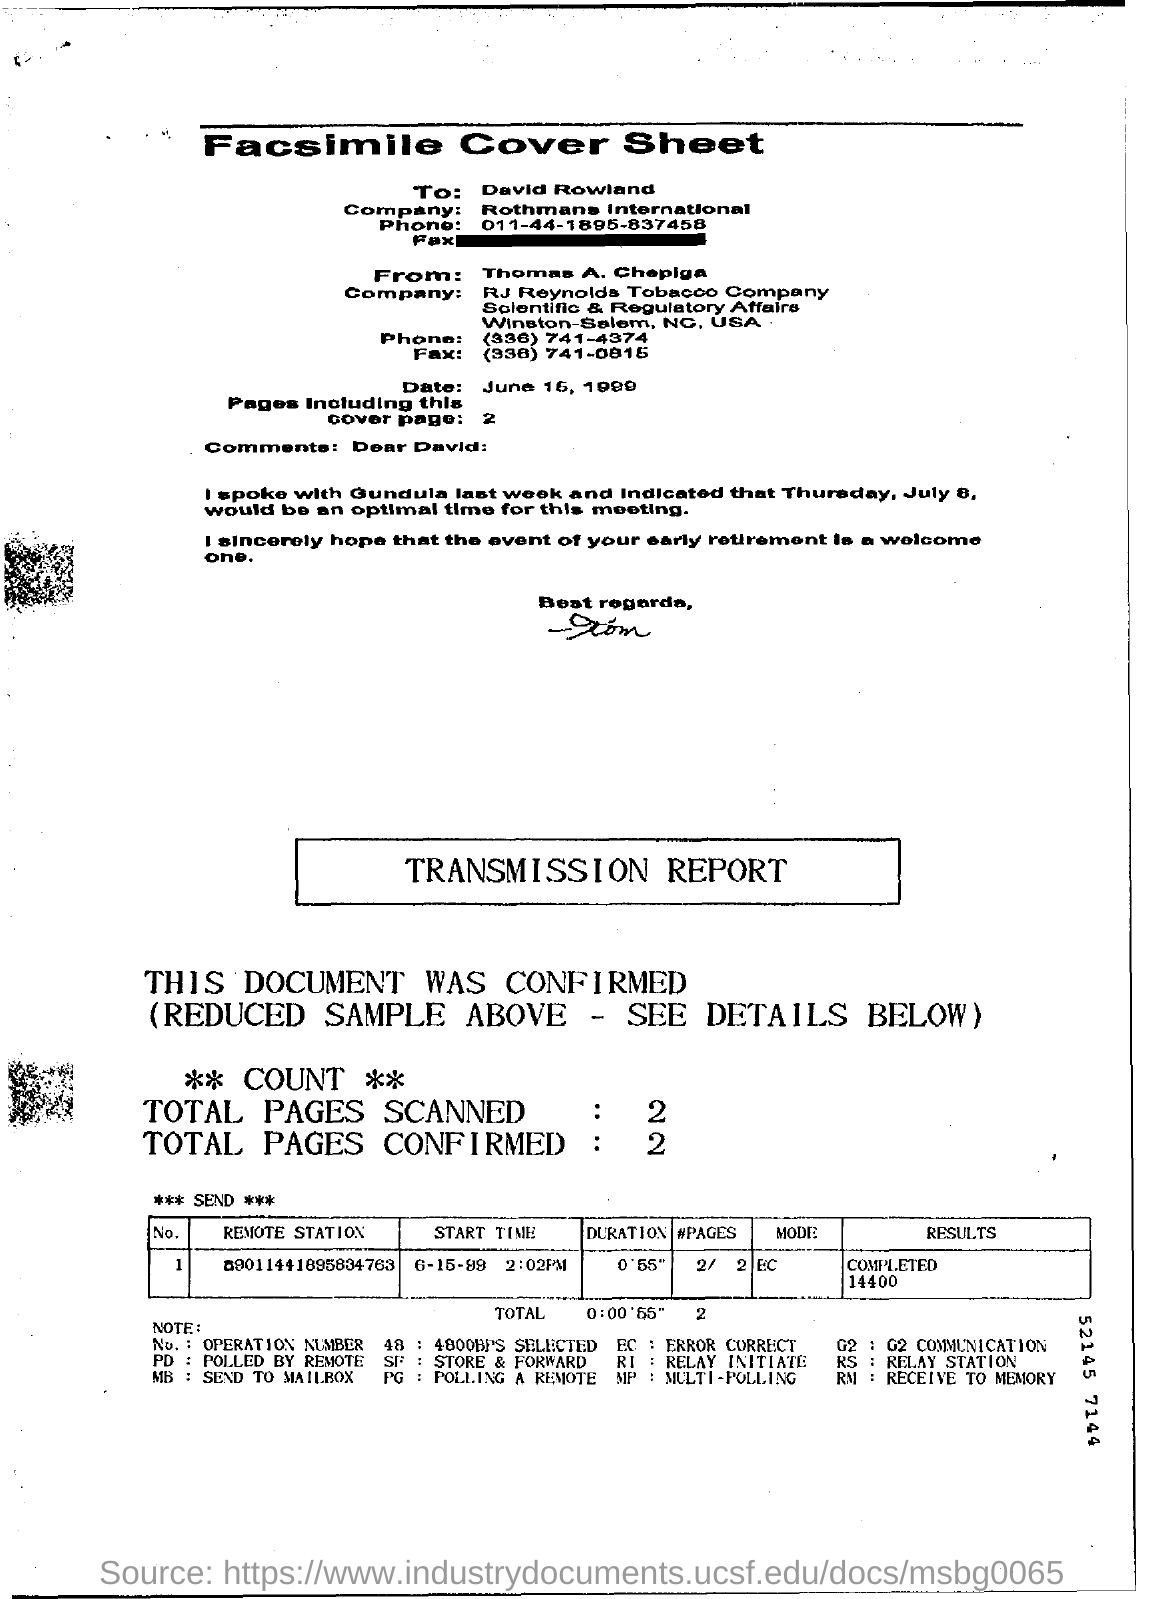To whom the cover sheet is written ?
Make the answer very short. David Rowland. To which company the cover sheet is sent ?
Make the answer very short. Rothmans international. How many pages are there including this cover page ?
Offer a terse response. 2. How many total pages are are scanned in the report ?
Offer a terse response. 2. How many total pages are confirmed in the report ?
Make the answer very short. 2. What is the duration mentioned in the report ?
Your answer should be very brief. 0'55". 